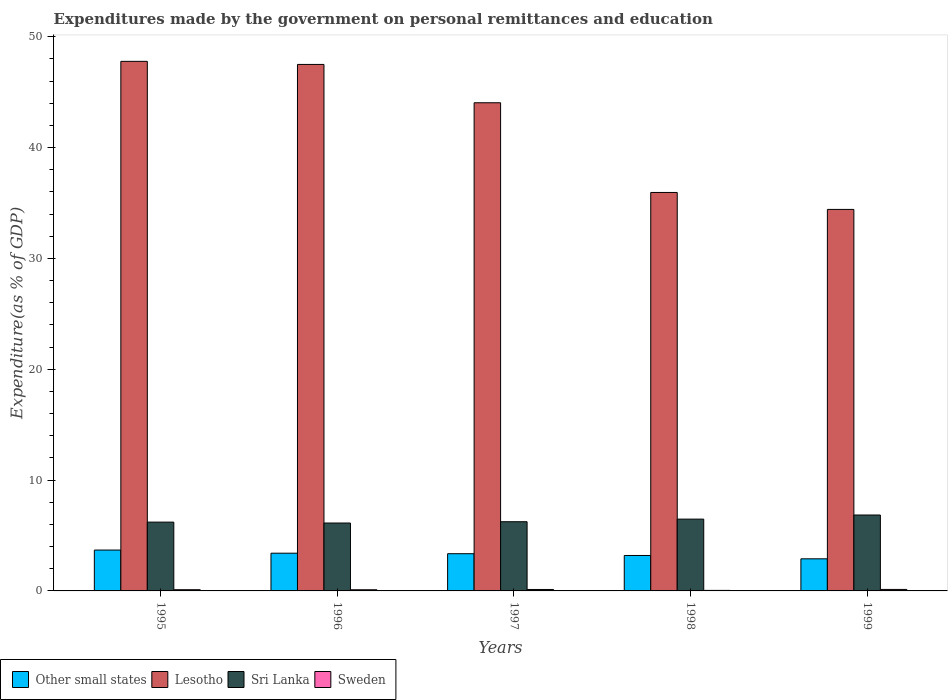How many groups of bars are there?
Your answer should be compact. 5. Are the number of bars on each tick of the X-axis equal?
Provide a succinct answer. Yes. How many bars are there on the 4th tick from the left?
Keep it short and to the point. 4. How many bars are there on the 1st tick from the right?
Provide a short and direct response. 4. What is the label of the 2nd group of bars from the left?
Keep it short and to the point. 1996. In how many cases, is the number of bars for a given year not equal to the number of legend labels?
Offer a very short reply. 0. What is the expenditures made by the government on personal remittances and education in Lesotho in 1999?
Offer a terse response. 34.43. Across all years, what is the maximum expenditures made by the government on personal remittances and education in Sweden?
Offer a very short reply. 0.13. Across all years, what is the minimum expenditures made by the government on personal remittances and education in Sweden?
Your response must be concise. 0.05. What is the total expenditures made by the government on personal remittances and education in Lesotho in the graph?
Keep it short and to the point. 209.73. What is the difference between the expenditures made by the government on personal remittances and education in Sweden in 1996 and that in 1998?
Make the answer very short. 0.06. What is the difference between the expenditures made by the government on personal remittances and education in Lesotho in 1996 and the expenditures made by the government on personal remittances and education in Sweden in 1995?
Provide a short and direct response. 47.4. What is the average expenditures made by the government on personal remittances and education in Sweden per year?
Keep it short and to the point. 0.11. In the year 1998, what is the difference between the expenditures made by the government on personal remittances and education in Sweden and expenditures made by the government on personal remittances and education in Other small states?
Offer a very short reply. -3.15. What is the ratio of the expenditures made by the government on personal remittances and education in Lesotho in 1995 to that in 1997?
Ensure brevity in your answer.  1.08. Is the expenditures made by the government on personal remittances and education in Sri Lanka in 1997 less than that in 1998?
Keep it short and to the point. Yes. What is the difference between the highest and the second highest expenditures made by the government on personal remittances and education in Sweden?
Offer a very short reply. 0. What is the difference between the highest and the lowest expenditures made by the government on personal remittances and education in Sri Lanka?
Offer a very short reply. 0.72. Is it the case that in every year, the sum of the expenditures made by the government on personal remittances and education in Lesotho and expenditures made by the government on personal remittances and education in Sweden is greater than the sum of expenditures made by the government on personal remittances and education in Other small states and expenditures made by the government on personal remittances and education in Sri Lanka?
Your response must be concise. Yes. What does the 3rd bar from the left in 1998 represents?
Your response must be concise. Sri Lanka. What does the 4th bar from the right in 1996 represents?
Make the answer very short. Other small states. Is it the case that in every year, the sum of the expenditures made by the government on personal remittances and education in Lesotho and expenditures made by the government on personal remittances and education in Sri Lanka is greater than the expenditures made by the government on personal remittances and education in Other small states?
Your answer should be very brief. Yes. How many bars are there?
Make the answer very short. 20. How many years are there in the graph?
Your answer should be compact. 5. Are the values on the major ticks of Y-axis written in scientific E-notation?
Provide a short and direct response. No. Does the graph contain any zero values?
Ensure brevity in your answer.  No. What is the title of the graph?
Provide a short and direct response. Expenditures made by the government on personal remittances and education. Does "Sudan" appear as one of the legend labels in the graph?
Give a very brief answer. No. What is the label or title of the Y-axis?
Offer a very short reply. Expenditure(as % of GDP). What is the Expenditure(as % of GDP) of Other small states in 1995?
Your answer should be compact. 3.69. What is the Expenditure(as % of GDP) in Lesotho in 1995?
Make the answer very short. 47.79. What is the Expenditure(as % of GDP) of Sri Lanka in 1995?
Your answer should be compact. 6.21. What is the Expenditure(as % of GDP) of Sweden in 1995?
Offer a very short reply. 0.11. What is the Expenditure(as % of GDP) in Other small states in 1996?
Offer a terse response. 3.4. What is the Expenditure(as % of GDP) in Lesotho in 1996?
Your answer should be compact. 47.51. What is the Expenditure(as % of GDP) in Sri Lanka in 1996?
Your answer should be very brief. 6.13. What is the Expenditure(as % of GDP) in Sweden in 1996?
Provide a succinct answer. 0.1. What is the Expenditure(as % of GDP) in Other small states in 1997?
Give a very brief answer. 3.36. What is the Expenditure(as % of GDP) in Lesotho in 1997?
Your response must be concise. 44.05. What is the Expenditure(as % of GDP) in Sri Lanka in 1997?
Your answer should be very brief. 6.24. What is the Expenditure(as % of GDP) in Sweden in 1997?
Provide a succinct answer. 0.13. What is the Expenditure(as % of GDP) in Other small states in 1998?
Keep it short and to the point. 3.2. What is the Expenditure(as % of GDP) in Lesotho in 1998?
Your answer should be very brief. 35.96. What is the Expenditure(as % of GDP) of Sri Lanka in 1998?
Your answer should be compact. 6.48. What is the Expenditure(as % of GDP) of Sweden in 1998?
Keep it short and to the point. 0.05. What is the Expenditure(as % of GDP) of Other small states in 1999?
Provide a short and direct response. 2.9. What is the Expenditure(as % of GDP) of Lesotho in 1999?
Provide a succinct answer. 34.43. What is the Expenditure(as % of GDP) in Sri Lanka in 1999?
Your answer should be very brief. 6.85. What is the Expenditure(as % of GDP) of Sweden in 1999?
Make the answer very short. 0.13. Across all years, what is the maximum Expenditure(as % of GDP) in Other small states?
Make the answer very short. 3.69. Across all years, what is the maximum Expenditure(as % of GDP) in Lesotho?
Your answer should be compact. 47.79. Across all years, what is the maximum Expenditure(as % of GDP) of Sri Lanka?
Offer a very short reply. 6.85. Across all years, what is the maximum Expenditure(as % of GDP) in Sweden?
Keep it short and to the point. 0.13. Across all years, what is the minimum Expenditure(as % of GDP) of Other small states?
Ensure brevity in your answer.  2.9. Across all years, what is the minimum Expenditure(as % of GDP) in Lesotho?
Ensure brevity in your answer.  34.43. Across all years, what is the minimum Expenditure(as % of GDP) of Sri Lanka?
Provide a succinct answer. 6.13. Across all years, what is the minimum Expenditure(as % of GDP) of Sweden?
Your response must be concise. 0.05. What is the total Expenditure(as % of GDP) of Other small states in the graph?
Give a very brief answer. 16.55. What is the total Expenditure(as % of GDP) in Lesotho in the graph?
Keep it short and to the point. 209.73. What is the total Expenditure(as % of GDP) in Sri Lanka in the graph?
Offer a terse response. 31.91. What is the total Expenditure(as % of GDP) in Sweden in the graph?
Offer a terse response. 0.53. What is the difference between the Expenditure(as % of GDP) of Other small states in 1995 and that in 1996?
Offer a terse response. 0.28. What is the difference between the Expenditure(as % of GDP) in Lesotho in 1995 and that in 1996?
Provide a succinct answer. 0.28. What is the difference between the Expenditure(as % of GDP) of Sri Lanka in 1995 and that in 1996?
Keep it short and to the point. 0.08. What is the difference between the Expenditure(as % of GDP) of Sweden in 1995 and that in 1996?
Offer a very short reply. 0. What is the difference between the Expenditure(as % of GDP) in Other small states in 1995 and that in 1997?
Provide a succinct answer. 0.33. What is the difference between the Expenditure(as % of GDP) in Lesotho in 1995 and that in 1997?
Ensure brevity in your answer.  3.74. What is the difference between the Expenditure(as % of GDP) in Sri Lanka in 1995 and that in 1997?
Your answer should be very brief. -0.04. What is the difference between the Expenditure(as % of GDP) in Sweden in 1995 and that in 1997?
Provide a succinct answer. -0.02. What is the difference between the Expenditure(as % of GDP) of Other small states in 1995 and that in 1998?
Your answer should be very brief. 0.49. What is the difference between the Expenditure(as % of GDP) of Lesotho in 1995 and that in 1998?
Your answer should be compact. 11.83. What is the difference between the Expenditure(as % of GDP) of Sri Lanka in 1995 and that in 1998?
Your answer should be very brief. -0.27. What is the difference between the Expenditure(as % of GDP) of Sweden in 1995 and that in 1998?
Give a very brief answer. 0.06. What is the difference between the Expenditure(as % of GDP) in Other small states in 1995 and that in 1999?
Keep it short and to the point. 0.79. What is the difference between the Expenditure(as % of GDP) of Lesotho in 1995 and that in 1999?
Keep it short and to the point. 13.36. What is the difference between the Expenditure(as % of GDP) in Sri Lanka in 1995 and that in 1999?
Keep it short and to the point. -0.64. What is the difference between the Expenditure(as % of GDP) of Sweden in 1995 and that in 1999?
Make the answer very short. -0.03. What is the difference between the Expenditure(as % of GDP) in Other small states in 1996 and that in 1997?
Offer a very short reply. 0.05. What is the difference between the Expenditure(as % of GDP) in Lesotho in 1996 and that in 1997?
Make the answer very short. 3.46. What is the difference between the Expenditure(as % of GDP) of Sri Lanka in 1996 and that in 1997?
Keep it short and to the point. -0.12. What is the difference between the Expenditure(as % of GDP) of Sweden in 1996 and that in 1997?
Offer a terse response. -0.03. What is the difference between the Expenditure(as % of GDP) of Other small states in 1996 and that in 1998?
Provide a short and direct response. 0.21. What is the difference between the Expenditure(as % of GDP) in Lesotho in 1996 and that in 1998?
Your response must be concise. 11.55. What is the difference between the Expenditure(as % of GDP) in Sri Lanka in 1996 and that in 1998?
Your answer should be compact. -0.35. What is the difference between the Expenditure(as % of GDP) in Sweden in 1996 and that in 1998?
Your response must be concise. 0.06. What is the difference between the Expenditure(as % of GDP) in Other small states in 1996 and that in 1999?
Offer a terse response. 0.51. What is the difference between the Expenditure(as % of GDP) in Lesotho in 1996 and that in 1999?
Offer a very short reply. 13.08. What is the difference between the Expenditure(as % of GDP) in Sri Lanka in 1996 and that in 1999?
Ensure brevity in your answer.  -0.72. What is the difference between the Expenditure(as % of GDP) of Sweden in 1996 and that in 1999?
Provide a short and direct response. -0.03. What is the difference between the Expenditure(as % of GDP) in Other small states in 1997 and that in 1998?
Give a very brief answer. 0.16. What is the difference between the Expenditure(as % of GDP) of Lesotho in 1997 and that in 1998?
Provide a short and direct response. 8.09. What is the difference between the Expenditure(as % of GDP) of Sri Lanka in 1997 and that in 1998?
Offer a very short reply. -0.24. What is the difference between the Expenditure(as % of GDP) in Sweden in 1997 and that in 1998?
Offer a terse response. 0.08. What is the difference between the Expenditure(as % of GDP) in Other small states in 1997 and that in 1999?
Your response must be concise. 0.46. What is the difference between the Expenditure(as % of GDP) in Lesotho in 1997 and that in 1999?
Your response must be concise. 9.62. What is the difference between the Expenditure(as % of GDP) in Sri Lanka in 1997 and that in 1999?
Your answer should be very brief. -0.61. What is the difference between the Expenditure(as % of GDP) in Sweden in 1997 and that in 1999?
Provide a succinct answer. -0. What is the difference between the Expenditure(as % of GDP) in Other small states in 1998 and that in 1999?
Ensure brevity in your answer.  0.3. What is the difference between the Expenditure(as % of GDP) in Lesotho in 1998 and that in 1999?
Your response must be concise. 1.53. What is the difference between the Expenditure(as % of GDP) of Sri Lanka in 1998 and that in 1999?
Keep it short and to the point. -0.37. What is the difference between the Expenditure(as % of GDP) in Sweden in 1998 and that in 1999?
Give a very brief answer. -0.09. What is the difference between the Expenditure(as % of GDP) of Other small states in 1995 and the Expenditure(as % of GDP) of Lesotho in 1996?
Provide a short and direct response. -43.82. What is the difference between the Expenditure(as % of GDP) in Other small states in 1995 and the Expenditure(as % of GDP) in Sri Lanka in 1996?
Make the answer very short. -2.44. What is the difference between the Expenditure(as % of GDP) in Other small states in 1995 and the Expenditure(as % of GDP) in Sweden in 1996?
Your answer should be compact. 3.58. What is the difference between the Expenditure(as % of GDP) of Lesotho in 1995 and the Expenditure(as % of GDP) of Sri Lanka in 1996?
Make the answer very short. 41.66. What is the difference between the Expenditure(as % of GDP) in Lesotho in 1995 and the Expenditure(as % of GDP) in Sweden in 1996?
Give a very brief answer. 47.68. What is the difference between the Expenditure(as % of GDP) in Sri Lanka in 1995 and the Expenditure(as % of GDP) in Sweden in 1996?
Provide a succinct answer. 6.1. What is the difference between the Expenditure(as % of GDP) in Other small states in 1995 and the Expenditure(as % of GDP) in Lesotho in 1997?
Keep it short and to the point. -40.36. What is the difference between the Expenditure(as % of GDP) of Other small states in 1995 and the Expenditure(as % of GDP) of Sri Lanka in 1997?
Offer a terse response. -2.56. What is the difference between the Expenditure(as % of GDP) in Other small states in 1995 and the Expenditure(as % of GDP) in Sweden in 1997?
Provide a short and direct response. 3.56. What is the difference between the Expenditure(as % of GDP) of Lesotho in 1995 and the Expenditure(as % of GDP) of Sri Lanka in 1997?
Offer a terse response. 41.54. What is the difference between the Expenditure(as % of GDP) in Lesotho in 1995 and the Expenditure(as % of GDP) in Sweden in 1997?
Offer a terse response. 47.66. What is the difference between the Expenditure(as % of GDP) in Sri Lanka in 1995 and the Expenditure(as % of GDP) in Sweden in 1997?
Your answer should be compact. 6.08. What is the difference between the Expenditure(as % of GDP) in Other small states in 1995 and the Expenditure(as % of GDP) in Lesotho in 1998?
Your response must be concise. -32.27. What is the difference between the Expenditure(as % of GDP) of Other small states in 1995 and the Expenditure(as % of GDP) of Sri Lanka in 1998?
Your answer should be very brief. -2.79. What is the difference between the Expenditure(as % of GDP) of Other small states in 1995 and the Expenditure(as % of GDP) of Sweden in 1998?
Your response must be concise. 3.64. What is the difference between the Expenditure(as % of GDP) of Lesotho in 1995 and the Expenditure(as % of GDP) of Sri Lanka in 1998?
Your answer should be compact. 41.31. What is the difference between the Expenditure(as % of GDP) in Lesotho in 1995 and the Expenditure(as % of GDP) in Sweden in 1998?
Make the answer very short. 47.74. What is the difference between the Expenditure(as % of GDP) in Sri Lanka in 1995 and the Expenditure(as % of GDP) in Sweden in 1998?
Provide a short and direct response. 6.16. What is the difference between the Expenditure(as % of GDP) in Other small states in 1995 and the Expenditure(as % of GDP) in Lesotho in 1999?
Offer a very short reply. -30.74. What is the difference between the Expenditure(as % of GDP) in Other small states in 1995 and the Expenditure(as % of GDP) in Sri Lanka in 1999?
Offer a very short reply. -3.16. What is the difference between the Expenditure(as % of GDP) of Other small states in 1995 and the Expenditure(as % of GDP) of Sweden in 1999?
Offer a very short reply. 3.55. What is the difference between the Expenditure(as % of GDP) of Lesotho in 1995 and the Expenditure(as % of GDP) of Sri Lanka in 1999?
Give a very brief answer. 40.94. What is the difference between the Expenditure(as % of GDP) in Lesotho in 1995 and the Expenditure(as % of GDP) in Sweden in 1999?
Give a very brief answer. 47.65. What is the difference between the Expenditure(as % of GDP) in Sri Lanka in 1995 and the Expenditure(as % of GDP) in Sweden in 1999?
Provide a succinct answer. 6.07. What is the difference between the Expenditure(as % of GDP) of Other small states in 1996 and the Expenditure(as % of GDP) of Lesotho in 1997?
Offer a terse response. -40.65. What is the difference between the Expenditure(as % of GDP) of Other small states in 1996 and the Expenditure(as % of GDP) of Sri Lanka in 1997?
Offer a very short reply. -2.84. What is the difference between the Expenditure(as % of GDP) of Other small states in 1996 and the Expenditure(as % of GDP) of Sweden in 1997?
Provide a short and direct response. 3.27. What is the difference between the Expenditure(as % of GDP) of Lesotho in 1996 and the Expenditure(as % of GDP) of Sri Lanka in 1997?
Provide a short and direct response. 41.27. What is the difference between the Expenditure(as % of GDP) in Lesotho in 1996 and the Expenditure(as % of GDP) in Sweden in 1997?
Make the answer very short. 47.38. What is the difference between the Expenditure(as % of GDP) in Sri Lanka in 1996 and the Expenditure(as % of GDP) in Sweden in 1997?
Your answer should be compact. 6. What is the difference between the Expenditure(as % of GDP) of Other small states in 1996 and the Expenditure(as % of GDP) of Lesotho in 1998?
Offer a terse response. -32.55. What is the difference between the Expenditure(as % of GDP) of Other small states in 1996 and the Expenditure(as % of GDP) of Sri Lanka in 1998?
Provide a short and direct response. -3.08. What is the difference between the Expenditure(as % of GDP) in Other small states in 1996 and the Expenditure(as % of GDP) in Sweden in 1998?
Your answer should be compact. 3.36. What is the difference between the Expenditure(as % of GDP) of Lesotho in 1996 and the Expenditure(as % of GDP) of Sri Lanka in 1998?
Make the answer very short. 41.03. What is the difference between the Expenditure(as % of GDP) of Lesotho in 1996 and the Expenditure(as % of GDP) of Sweden in 1998?
Make the answer very short. 47.46. What is the difference between the Expenditure(as % of GDP) of Sri Lanka in 1996 and the Expenditure(as % of GDP) of Sweden in 1998?
Provide a short and direct response. 6.08. What is the difference between the Expenditure(as % of GDP) in Other small states in 1996 and the Expenditure(as % of GDP) in Lesotho in 1999?
Offer a terse response. -31.02. What is the difference between the Expenditure(as % of GDP) in Other small states in 1996 and the Expenditure(as % of GDP) in Sri Lanka in 1999?
Provide a short and direct response. -3.45. What is the difference between the Expenditure(as % of GDP) in Other small states in 1996 and the Expenditure(as % of GDP) in Sweden in 1999?
Ensure brevity in your answer.  3.27. What is the difference between the Expenditure(as % of GDP) of Lesotho in 1996 and the Expenditure(as % of GDP) of Sri Lanka in 1999?
Make the answer very short. 40.66. What is the difference between the Expenditure(as % of GDP) of Lesotho in 1996 and the Expenditure(as % of GDP) of Sweden in 1999?
Your response must be concise. 47.38. What is the difference between the Expenditure(as % of GDP) in Sri Lanka in 1996 and the Expenditure(as % of GDP) in Sweden in 1999?
Your answer should be very brief. 5.99. What is the difference between the Expenditure(as % of GDP) in Other small states in 1997 and the Expenditure(as % of GDP) in Lesotho in 1998?
Your answer should be very brief. -32.6. What is the difference between the Expenditure(as % of GDP) of Other small states in 1997 and the Expenditure(as % of GDP) of Sri Lanka in 1998?
Offer a terse response. -3.12. What is the difference between the Expenditure(as % of GDP) in Other small states in 1997 and the Expenditure(as % of GDP) in Sweden in 1998?
Offer a terse response. 3.31. What is the difference between the Expenditure(as % of GDP) of Lesotho in 1997 and the Expenditure(as % of GDP) of Sri Lanka in 1998?
Offer a terse response. 37.57. What is the difference between the Expenditure(as % of GDP) in Lesotho in 1997 and the Expenditure(as % of GDP) in Sweden in 1998?
Your answer should be compact. 44. What is the difference between the Expenditure(as % of GDP) in Sri Lanka in 1997 and the Expenditure(as % of GDP) in Sweden in 1998?
Your answer should be very brief. 6.2. What is the difference between the Expenditure(as % of GDP) of Other small states in 1997 and the Expenditure(as % of GDP) of Lesotho in 1999?
Your answer should be compact. -31.07. What is the difference between the Expenditure(as % of GDP) in Other small states in 1997 and the Expenditure(as % of GDP) in Sri Lanka in 1999?
Ensure brevity in your answer.  -3.49. What is the difference between the Expenditure(as % of GDP) in Other small states in 1997 and the Expenditure(as % of GDP) in Sweden in 1999?
Provide a short and direct response. 3.22. What is the difference between the Expenditure(as % of GDP) of Lesotho in 1997 and the Expenditure(as % of GDP) of Sri Lanka in 1999?
Your answer should be very brief. 37.2. What is the difference between the Expenditure(as % of GDP) of Lesotho in 1997 and the Expenditure(as % of GDP) of Sweden in 1999?
Keep it short and to the point. 43.92. What is the difference between the Expenditure(as % of GDP) of Sri Lanka in 1997 and the Expenditure(as % of GDP) of Sweden in 1999?
Make the answer very short. 6.11. What is the difference between the Expenditure(as % of GDP) of Other small states in 1998 and the Expenditure(as % of GDP) of Lesotho in 1999?
Offer a terse response. -31.23. What is the difference between the Expenditure(as % of GDP) of Other small states in 1998 and the Expenditure(as % of GDP) of Sri Lanka in 1999?
Offer a very short reply. -3.65. What is the difference between the Expenditure(as % of GDP) in Other small states in 1998 and the Expenditure(as % of GDP) in Sweden in 1999?
Provide a succinct answer. 3.06. What is the difference between the Expenditure(as % of GDP) in Lesotho in 1998 and the Expenditure(as % of GDP) in Sri Lanka in 1999?
Offer a very short reply. 29.11. What is the difference between the Expenditure(as % of GDP) in Lesotho in 1998 and the Expenditure(as % of GDP) in Sweden in 1999?
Ensure brevity in your answer.  35.82. What is the difference between the Expenditure(as % of GDP) of Sri Lanka in 1998 and the Expenditure(as % of GDP) of Sweden in 1999?
Make the answer very short. 6.35. What is the average Expenditure(as % of GDP) of Other small states per year?
Provide a succinct answer. 3.31. What is the average Expenditure(as % of GDP) of Lesotho per year?
Provide a succinct answer. 41.95. What is the average Expenditure(as % of GDP) of Sri Lanka per year?
Keep it short and to the point. 6.38. What is the average Expenditure(as % of GDP) of Sweden per year?
Your answer should be very brief. 0.1. In the year 1995, what is the difference between the Expenditure(as % of GDP) in Other small states and Expenditure(as % of GDP) in Lesotho?
Your response must be concise. -44.1. In the year 1995, what is the difference between the Expenditure(as % of GDP) in Other small states and Expenditure(as % of GDP) in Sri Lanka?
Keep it short and to the point. -2.52. In the year 1995, what is the difference between the Expenditure(as % of GDP) in Other small states and Expenditure(as % of GDP) in Sweden?
Provide a succinct answer. 3.58. In the year 1995, what is the difference between the Expenditure(as % of GDP) in Lesotho and Expenditure(as % of GDP) in Sri Lanka?
Offer a terse response. 41.58. In the year 1995, what is the difference between the Expenditure(as % of GDP) of Lesotho and Expenditure(as % of GDP) of Sweden?
Provide a short and direct response. 47.68. In the year 1995, what is the difference between the Expenditure(as % of GDP) in Sri Lanka and Expenditure(as % of GDP) in Sweden?
Your answer should be very brief. 6.1. In the year 1996, what is the difference between the Expenditure(as % of GDP) of Other small states and Expenditure(as % of GDP) of Lesotho?
Your answer should be compact. -44.11. In the year 1996, what is the difference between the Expenditure(as % of GDP) of Other small states and Expenditure(as % of GDP) of Sri Lanka?
Offer a terse response. -2.72. In the year 1996, what is the difference between the Expenditure(as % of GDP) of Other small states and Expenditure(as % of GDP) of Sweden?
Provide a succinct answer. 3.3. In the year 1996, what is the difference between the Expenditure(as % of GDP) in Lesotho and Expenditure(as % of GDP) in Sri Lanka?
Ensure brevity in your answer.  41.38. In the year 1996, what is the difference between the Expenditure(as % of GDP) in Lesotho and Expenditure(as % of GDP) in Sweden?
Your answer should be compact. 47.41. In the year 1996, what is the difference between the Expenditure(as % of GDP) of Sri Lanka and Expenditure(as % of GDP) of Sweden?
Give a very brief answer. 6.02. In the year 1997, what is the difference between the Expenditure(as % of GDP) in Other small states and Expenditure(as % of GDP) in Lesotho?
Make the answer very short. -40.69. In the year 1997, what is the difference between the Expenditure(as % of GDP) in Other small states and Expenditure(as % of GDP) in Sri Lanka?
Ensure brevity in your answer.  -2.89. In the year 1997, what is the difference between the Expenditure(as % of GDP) of Other small states and Expenditure(as % of GDP) of Sweden?
Your answer should be compact. 3.23. In the year 1997, what is the difference between the Expenditure(as % of GDP) in Lesotho and Expenditure(as % of GDP) in Sri Lanka?
Offer a very short reply. 37.81. In the year 1997, what is the difference between the Expenditure(as % of GDP) in Lesotho and Expenditure(as % of GDP) in Sweden?
Keep it short and to the point. 43.92. In the year 1997, what is the difference between the Expenditure(as % of GDP) in Sri Lanka and Expenditure(as % of GDP) in Sweden?
Give a very brief answer. 6.11. In the year 1998, what is the difference between the Expenditure(as % of GDP) of Other small states and Expenditure(as % of GDP) of Lesotho?
Your answer should be very brief. -32.76. In the year 1998, what is the difference between the Expenditure(as % of GDP) in Other small states and Expenditure(as % of GDP) in Sri Lanka?
Your answer should be compact. -3.28. In the year 1998, what is the difference between the Expenditure(as % of GDP) of Other small states and Expenditure(as % of GDP) of Sweden?
Offer a terse response. 3.15. In the year 1998, what is the difference between the Expenditure(as % of GDP) of Lesotho and Expenditure(as % of GDP) of Sri Lanka?
Provide a succinct answer. 29.48. In the year 1998, what is the difference between the Expenditure(as % of GDP) in Lesotho and Expenditure(as % of GDP) in Sweden?
Your answer should be compact. 35.91. In the year 1998, what is the difference between the Expenditure(as % of GDP) of Sri Lanka and Expenditure(as % of GDP) of Sweden?
Your answer should be very brief. 6.43. In the year 1999, what is the difference between the Expenditure(as % of GDP) of Other small states and Expenditure(as % of GDP) of Lesotho?
Ensure brevity in your answer.  -31.53. In the year 1999, what is the difference between the Expenditure(as % of GDP) of Other small states and Expenditure(as % of GDP) of Sri Lanka?
Keep it short and to the point. -3.95. In the year 1999, what is the difference between the Expenditure(as % of GDP) in Other small states and Expenditure(as % of GDP) in Sweden?
Your answer should be compact. 2.76. In the year 1999, what is the difference between the Expenditure(as % of GDP) of Lesotho and Expenditure(as % of GDP) of Sri Lanka?
Your answer should be very brief. 27.58. In the year 1999, what is the difference between the Expenditure(as % of GDP) of Lesotho and Expenditure(as % of GDP) of Sweden?
Ensure brevity in your answer.  34.29. In the year 1999, what is the difference between the Expenditure(as % of GDP) in Sri Lanka and Expenditure(as % of GDP) in Sweden?
Make the answer very short. 6.72. What is the ratio of the Expenditure(as % of GDP) of Other small states in 1995 to that in 1996?
Ensure brevity in your answer.  1.08. What is the ratio of the Expenditure(as % of GDP) of Lesotho in 1995 to that in 1996?
Ensure brevity in your answer.  1.01. What is the ratio of the Expenditure(as % of GDP) of Sri Lanka in 1995 to that in 1996?
Give a very brief answer. 1.01. What is the ratio of the Expenditure(as % of GDP) in Sweden in 1995 to that in 1996?
Provide a short and direct response. 1.04. What is the ratio of the Expenditure(as % of GDP) in Other small states in 1995 to that in 1997?
Provide a short and direct response. 1.1. What is the ratio of the Expenditure(as % of GDP) in Lesotho in 1995 to that in 1997?
Provide a succinct answer. 1.08. What is the ratio of the Expenditure(as % of GDP) in Sweden in 1995 to that in 1997?
Keep it short and to the point. 0.84. What is the ratio of the Expenditure(as % of GDP) of Other small states in 1995 to that in 1998?
Provide a succinct answer. 1.15. What is the ratio of the Expenditure(as % of GDP) in Lesotho in 1995 to that in 1998?
Make the answer very short. 1.33. What is the ratio of the Expenditure(as % of GDP) in Sri Lanka in 1995 to that in 1998?
Keep it short and to the point. 0.96. What is the ratio of the Expenditure(as % of GDP) in Sweden in 1995 to that in 1998?
Your answer should be compact. 2.31. What is the ratio of the Expenditure(as % of GDP) of Other small states in 1995 to that in 1999?
Offer a terse response. 1.27. What is the ratio of the Expenditure(as % of GDP) of Lesotho in 1995 to that in 1999?
Your response must be concise. 1.39. What is the ratio of the Expenditure(as % of GDP) of Sri Lanka in 1995 to that in 1999?
Offer a terse response. 0.91. What is the ratio of the Expenditure(as % of GDP) of Sweden in 1995 to that in 1999?
Your response must be concise. 0.81. What is the ratio of the Expenditure(as % of GDP) in Other small states in 1996 to that in 1997?
Give a very brief answer. 1.01. What is the ratio of the Expenditure(as % of GDP) of Lesotho in 1996 to that in 1997?
Offer a terse response. 1.08. What is the ratio of the Expenditure(as % of GDP) of Sri Lanka in 1996 to that in 1997?
Your answer should be compact. 0.98. What is the ratio of the Expenditure(as % of GDP) in Sweden in 1996 to that in 1997?
Provide a succinct answer. 0.8. What is the ratio of the Expenditure(as % of GDP) in Other small states in 1996 to that in 1998?
Offer a very short reply. 1.06. What is the ratio of the Expenditure(as % of GDP) of Lesotho in 1996 to that in 1998?
Ensure brevity in your answer.  1.32. What is the ratio of the Expenditure(as % of GDP) in Sri Lanka in 1996 to that in 1998?
Provide a short and direct response. 0.95. What is the ratio of the Expenditure(as % of GDP) in Sweden in 1996 to that in 1998?
Keep it short and to the point. 2.22. What is the ratio of the Expenditure(as % of GDP) in Other small states in 1996 to that in 1999?
Give a very brief answer. 1.17. What is the ratio of the Expenditure(as % of GDP) of Lesotho in 1996 to that in 1999?
Provide a succinct answer. 1.38. What is the ratio of the Expenditure(as % of GDP) in Sri Lanka in 1996 to that in 1999?
Make the answer very short. 0.89. What is the ratio of the Expenditure(as % of GDP) of Sweden in 1996 to that in 1999?
Make the answer very short. 0.78. What is the ratio of the Expenditure(as % of GDP) of Lesotho in 1997 to that in 1998?
Your answer should be very brief. 1.23. What is the ratio of the Expenditure(as % of GDP) of Sri Lanka in 1997 to that in 1998?
Keep it short and to the point. 0.96. What is the ratio of the Expenditure(as % of GDP) of Sweden in 1997 to that in 1998?
Provide a succinct answer. 2.77. What is the ratio of the Expenditure(as % of GDP) of Other small states in 1997 to that in 1999?
Ensure brevity in your answer.  1.16. What is the ratio of the Expenditure(as % of GDP) of Lesotho in 1997 to that in 1999?
Offer a terse response. 1.28. What is the ratio of the Expenditure(as % of GDP) in Sri Lanka in 1997 to that in 1999?
Offer a very short reply. 0.91. What is the ratio of the Expenditure(as % of GDP) of Sweden in 1997 to that in 1999?
Make the answer very short. 0.97. What is the ratio of the Expenditure(as % of GDP) in Other small states in 1998 to that in 1999?
Offer a very short reply. 1.1. What is the ratio of the Expenditure(as % of GDP) in Lesotho in 1998 to that in 1999?
Your response must be concise. 1.04. What is the ratio of the Expenditure(as % of GDP) of Sri Lanka in 1998 to that in 1999?
Provide a succinct answer. 0.95. What is the ratio of the Expenditure(as % of GDP) of Sweden in 1998 to that in 1999?
Give a very brief answer. 0.35. What is the difference between the highest and the second highest Expenditure(as % of GDP) in Other small states?
Provide a short and direct response. 0.28. What is the difference between the highest and the second highest Expenditure(as % of GDP) in Lesotho?
Make the answer very short. 0.28. What is the difference between the highest and the second highest Expenditure(as % of GDP) in Sri Lanka?
Provide a succinct answer. 0.37. What is the difference between the highest and the second highest Expenditure(as % of GDP) in Sweden?
Offer a very short reply. 0. What is the difference between the highest and the lowest Expenditure(as % of GDP) in Other small states?
Give a very brief answer. 0.79. What is the difference between the highest and the lowest Expenditure(as % of GDP) of Lesotho?
Give a very brief answer. 13.36. What is the difference between the highest and the lowest Expenditure(as % of GDP) of Sri Lanka?
Your answer should be compact. 0.72. What is the difference between the highest and the lowest Expenditure(as % of GDP) of Sweden?
Give a very brief answer. 0.09. 